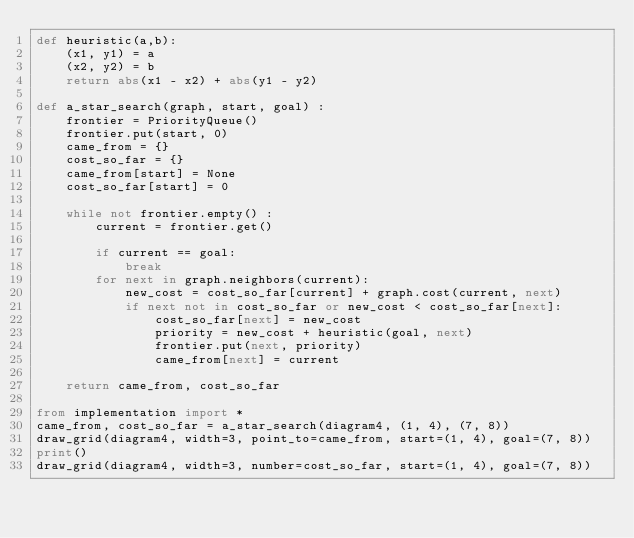Convert code to text. <code><loc_0><loc_0><loc_500><loc_500><_Python_>def heuristic(a,b):
    (x1, y1) = a
    (x2, y2) = b
    return abs(x1 - x2) + abs(y1 - y2)

def a_star_search(graph, start, goal) : 
    frontier = PriorityQueue()
    frontier.put(start, 0)
    came_from = {}
    cost_so_far = {}
    came_from[start] = None
    cost_so_far[start] = 0

    while not frontier.empty() :
        current = frontier.get()

        if current == goal:
            break
        for next in graph.neighbors(current):
            new_cost = cost_so_far[current] + graph.cost(current, next)
            if next not in cost_so_far or new_cost < cost_so_far[next]:
                cost_so_far[next] = new_cost
                priority = new_cost + heuristic(goal, next)
                frontier.put(next, priority)
                came_from[next] = current
        
    return came_from, cost_so_far

from implementation import *
came_from, cost_so_far = a_star_search(diagram4, (1, 4), (7, 8))
draw_grid(diagram4, width=3, point_to=came_from, start=(1, 4), goal=(7, 8))
print()
draw_grid(diagram4, width=3, number=cost_so_far, start=(1, 4), goal=(7, 8))</code> 